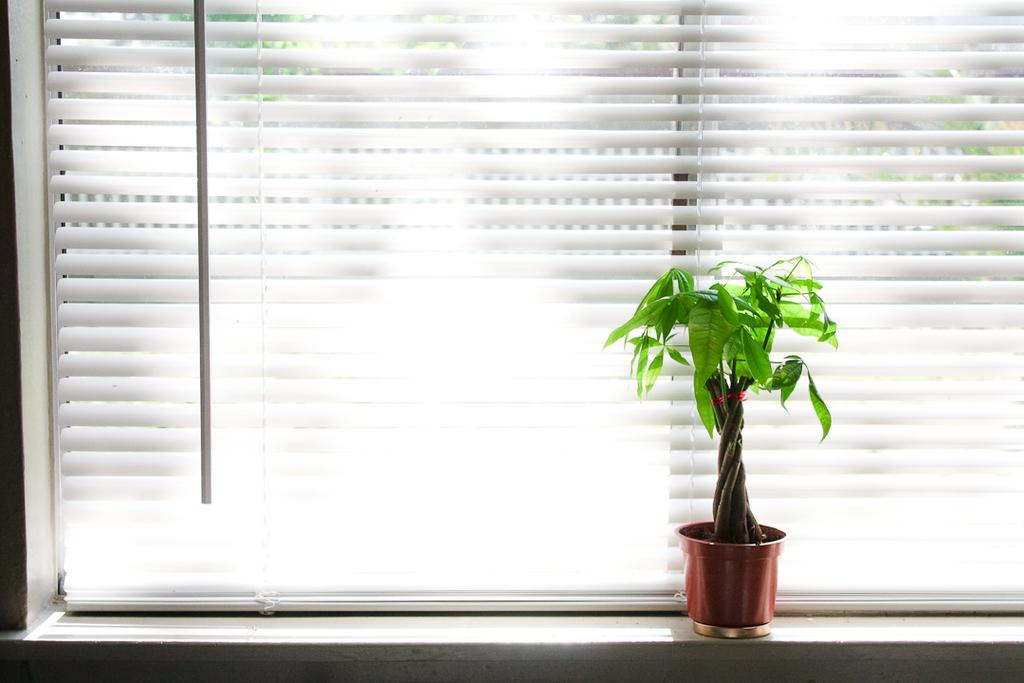What type of living organism can be seen in the image? There is a plant in the image. What is located behind the plant in the image? There is a window blind behind the plant in the image. What type of silver spot can be seen on the street in the image? There is no street or silver spot present in the image; it only features a plant and a window blind. 